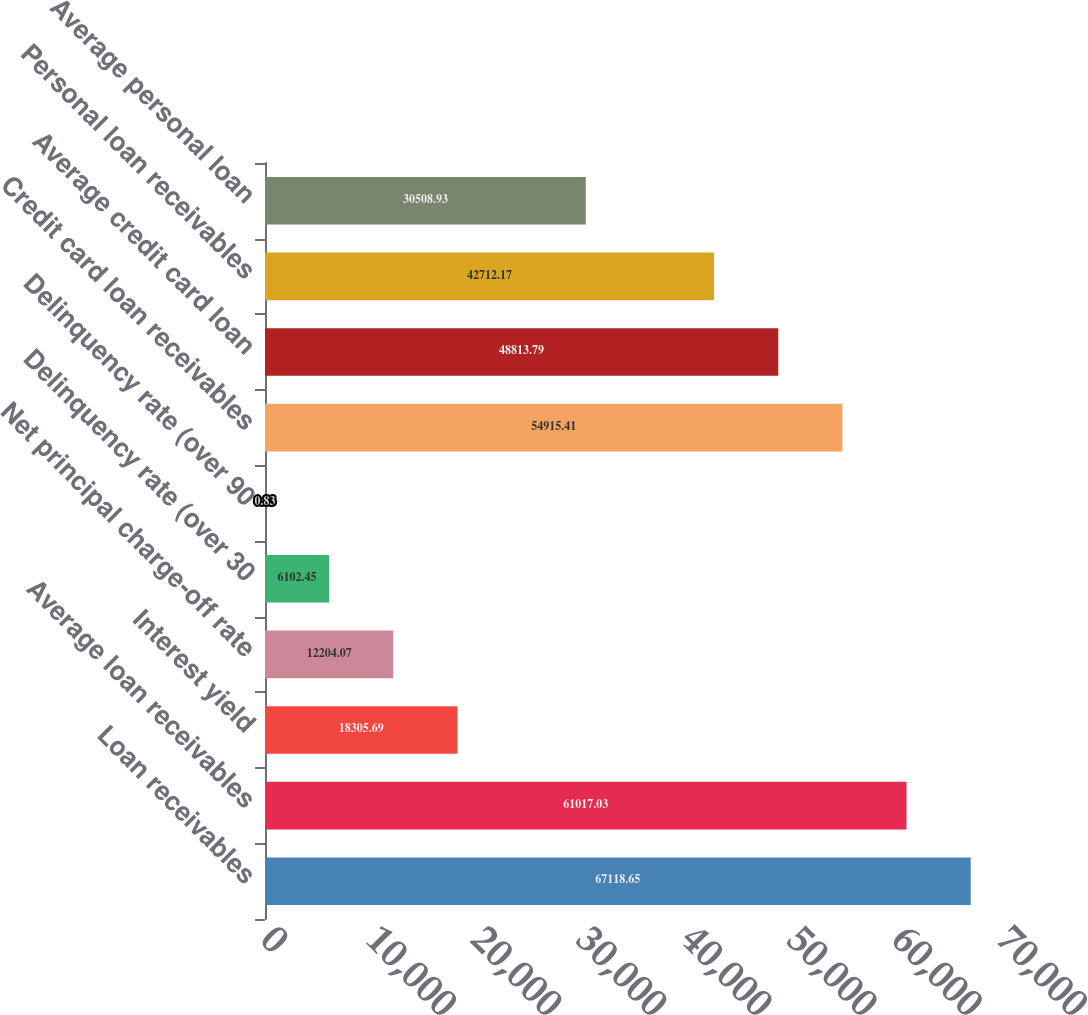<chart> <loc_0><loc_0><loc_500><loc_500><bar_chart><fcel>Loan receivables<fcel>Average loan receivables<fcel>Interest yield<fcel>Net principal charge-off rate<fcel>Delinquency rate (over 30<fcel>Delinquency rate (over 90<fcel>Credit card loan receivables<fcel>Average credit card loan<fcel>Personal loan receivables<fcel>Average personal loan<nl><fcel>67118.6<fcel>61017<fcel>18305.7<fcel>12204.1<fcel>6102.45<fcel>0.83<fcel>54915.4<fcel>48813.8<fcel>42712.2<fcel>30508.9<nl></chart> 